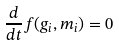<formula> <loc_0><loc_0><loc_500><loc_500>\frac { d } { d t } f ( g _ { i } , m _ { i } ) = 0</formula> 